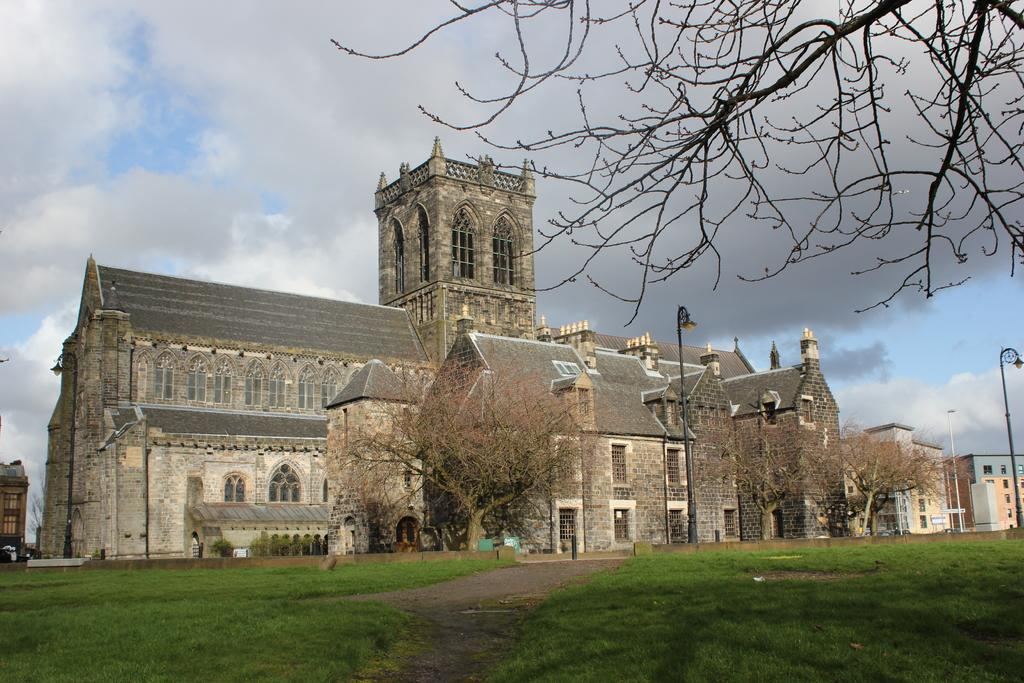What type of structures can be seen in the image? There are buildings in the image. What type of vegetation is present in the image? There are trees in the image. What type of lighting is present in the image? There are street lights in the image. What type of ground cover is visible in the image? There is grass visible in the image. What other objects can be seen on the ground in the image? There are other objects on the ground. What can be seen in the background of the image? The sky is visible in the background of the image. Where is the zebra located in the image? There is no zebra present in the image. What type of alley is visible in the image? There is no alley present in the image. 